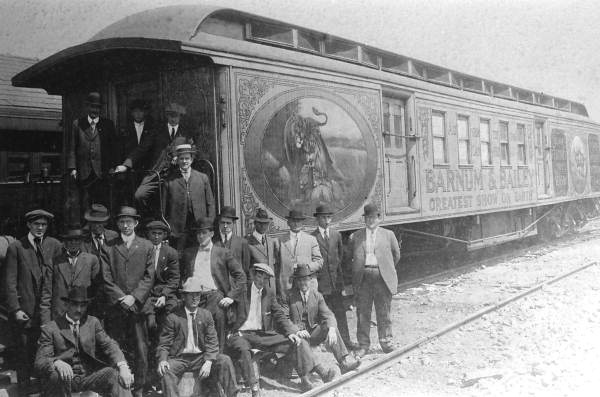Describe the objects in this image and their specific colors. I can see train in darkgray, gray, lightgray, and black tones, people in darkgray, gray, black, and lightgray tones, train in black, gray, and darkgray tones, people in darkgray, black, gray, and lightgray tones, and people in darkgray, black, gray, and lightgray tones in this image. 